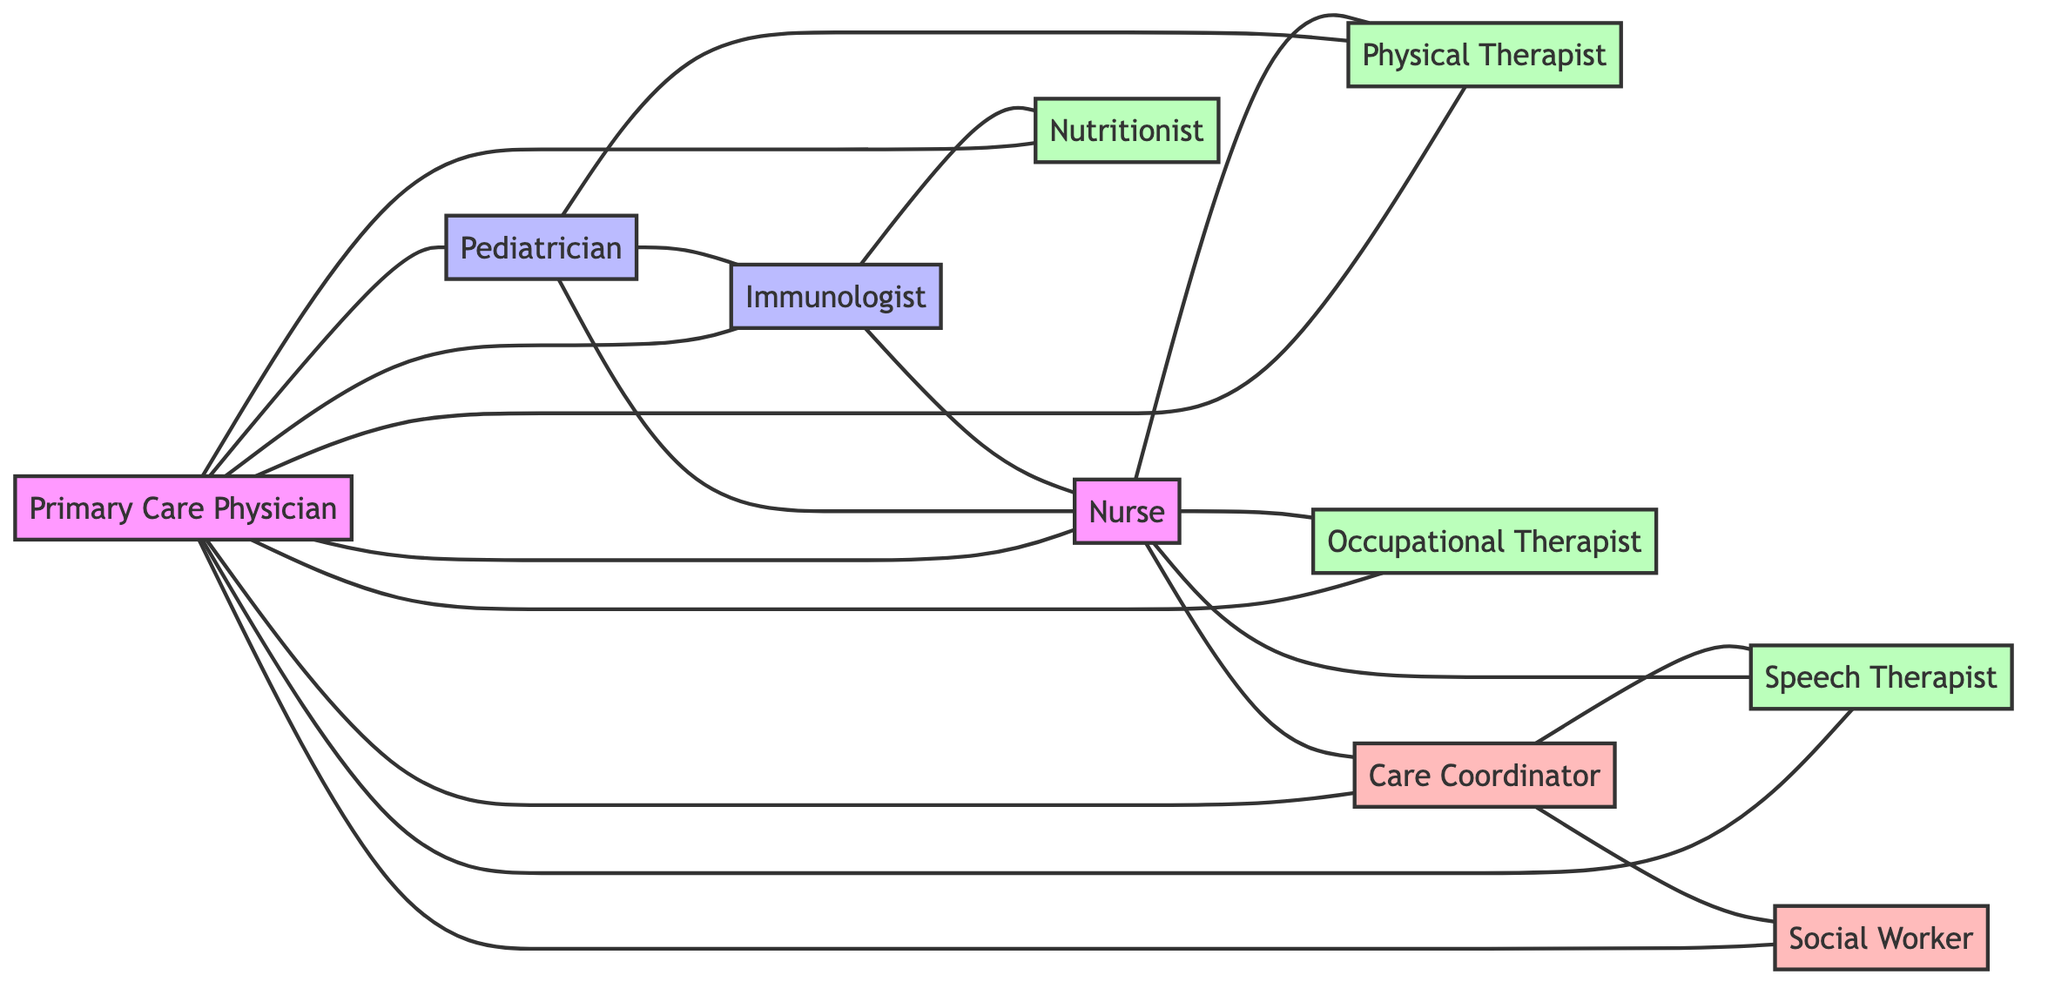What's the total number of nodes in the diagram? By counting the different types of care providers represented, including the primary care physician, specialists, nurses, therapists, and support roles, we find there are 10 distinct nodes listed.
Answer: 10 Which node has the most connections? The Primary Care Physician connects to 9 other nodes directly, indicating that it plays a central role in the care network by linking with several specialists and support staff.
Answer: Primary Care Physician How many types of therapists are present in the diagram? We can identify the distinct categories of therapists listed, which include Physical Therapist, Occupational Therapist, and Speech Therapist, totaling to 3 types.
Answer: 3 What is the relationship between the Pediatrician and the Immunologist? The Pediatrician and Immunologist are directly connected, indicating that there is a collaborative relationship in patient care strategies.
Answer: Connected Which support role is linked to the Care Coordinator? The Care Coordinator has connections to both the Social Worker and Speech Therapist, establishing its support function in the overall care structure.
Answer: Social Worker, Speech Therapist How many direct connections does the Nurse have? By counting the edges from the Nurse node, we see there are 5 direct connections to the Physical Therapist, Occupational Therapist, Speech Therapist, Immunologist, and Care Coordinator.
Answer: 5 Which type of care provider connects the Pediatrician and the Physical Therapist? The diagram shows the Primary Care Physician acting as a connecting node between the Pediatrician and the Physical Therapist, facilitating communication and care coordination.
Answer: Primary Care Physician How many edges are there in total in the diagram? By counting all direct connections (edges) between the nodes, we find there are 20 edges linking the various care providers in this medical support team.
Answer: 20 Which therapy professional is linked to the Immunologist? The Nutritionist is directly connected to the Immunologist, suggesting their role in developing dietary plans that complement medical treatment.
Answer: Nutritionist 